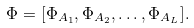Convert formula to latex. <formula><loc_0><loc_0><loc_500><loc_500>\Phi = [ \Phi _ { A _ { 1 } } , \Phi _ { A _ { 2 } } , \dots , \Phi _ { A _ { L } } ] .</formula> 